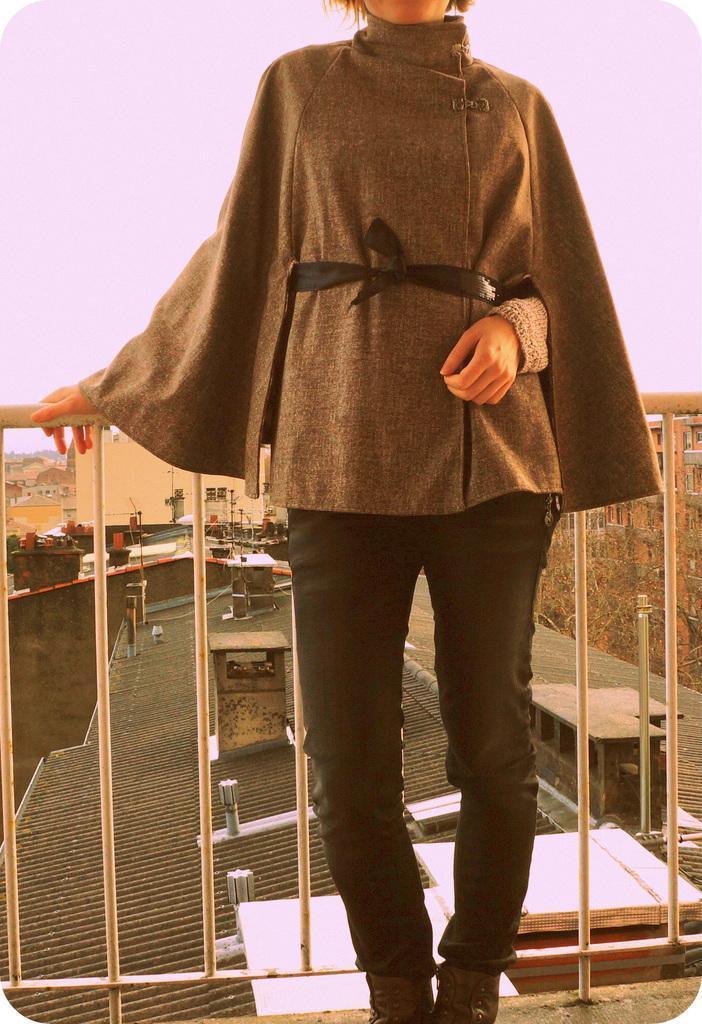In one or two sentences, can you explain what this image depicts? In the middle of this image, there is a woman in a brown color jacket, standing and holding a fence with a hand. In the background, there are trees and buildings on the ground and there are clouds in the sky. 